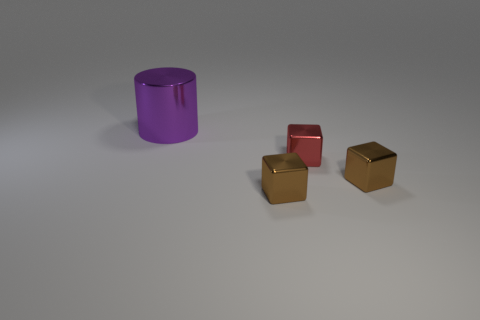Add 3 brown metallic blocks. How many objects exist? 7 Subtract all cylinders. How many objects are left? 3 Subtract 0 purple balls. How many objects are left? 4 Subtract all red objects. Subtract all brown metallic cubes. How many objects are left? 1 Add 3 big objects. How many big objects are left? 4 Add 3 red blocks. How many red blocks exist? 4 